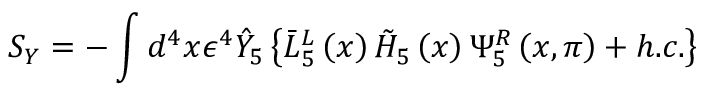<formula> <loc_0><loc_0><loc_500><loc_500>S _ { Y } = - \int d ^ { 4 } x \epsilon ^ { 4 } \hat { Y } _ { 5 } \left \{ \bar { L } _ { 5 } ^ { L } \left ( x \right ) \tilde { H } _ { 5 } \left ( x \right ) \Psi _ { 5 } ^ { R } \left ( x , \pi \right ) + h . c . \right \}</formula> 